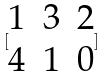Convert formula to latex. <formula><loc_0><loc_0><loc_500><loc_500>[ \begin{matrix} 1 & 3 & 2 \\ 4 & 1 & 0 \end{matrix} ]</formula> 